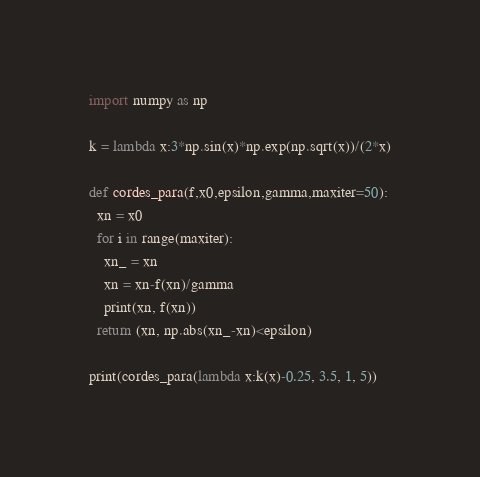<code> <loc_0><loc_0><loc_500><loc_500><_Python_>import numpy as np

k = lambda x:3*np.sin(x)*np.exp(np.sqrt(x))/(2*x)

def cordes_para(f,x0,epsilon,gamma,maxiter=50):
  xn = x0
  for i in range(maxiter):
    xn_ = xn
    xn = xn-f(xn)/gamma
    print(xn, f(xn))
  return (xn, np.abs(xn_-xn)<epsilon)

print(cordes_para(lambda x:k(x)-0.25, 3.5, 1, 5))
</code> 